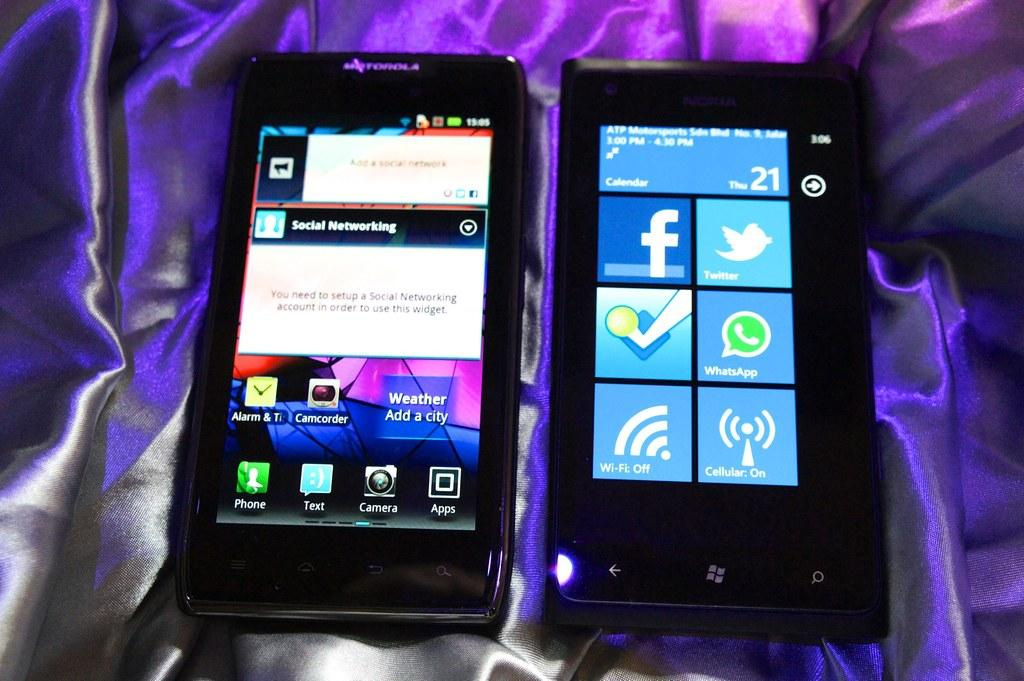<image>
Summarize the visual content of the image. The phone needs to be connected to a social networking account for the home screen widget to work. 